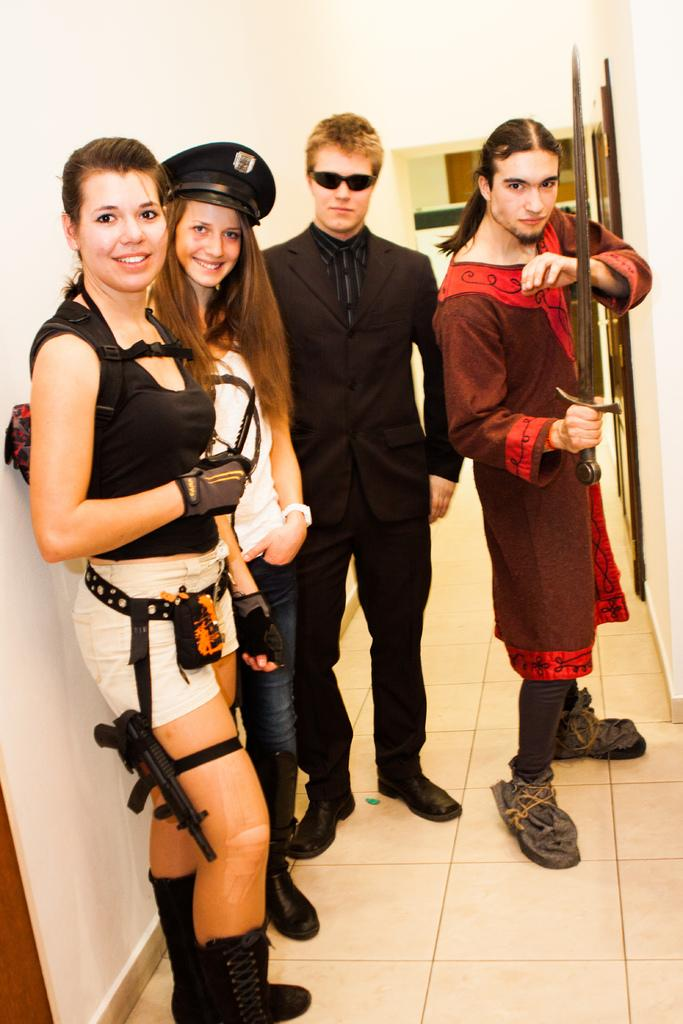How many people are in the image? There is a group of people in the image. What are the people doing in the image? Some people are smiling, and a man is holding a sword. Can you describe the man holding the sword? The man holding the sword is standing beside another man who is wearing spectacles. What type of paste is being used in the meeting depicted in the image? There is no meeting or paste present in the image; it features a group of people with some smiling and a man holding a sword. 